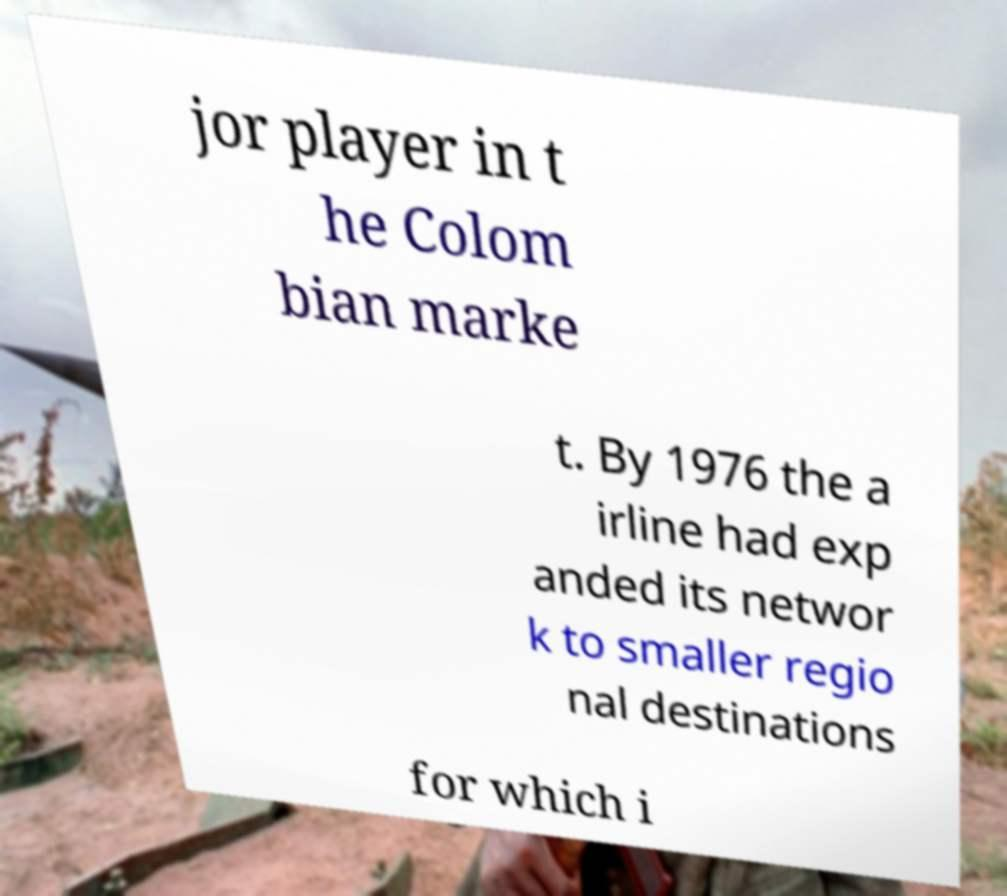For documentation purposes, I need the text within this image transcribed. Could you provide that? jor player in t he Colom bian marke t. By 1976 the a irline had exp anded its networ k to smaller regio nal destinations for which i 